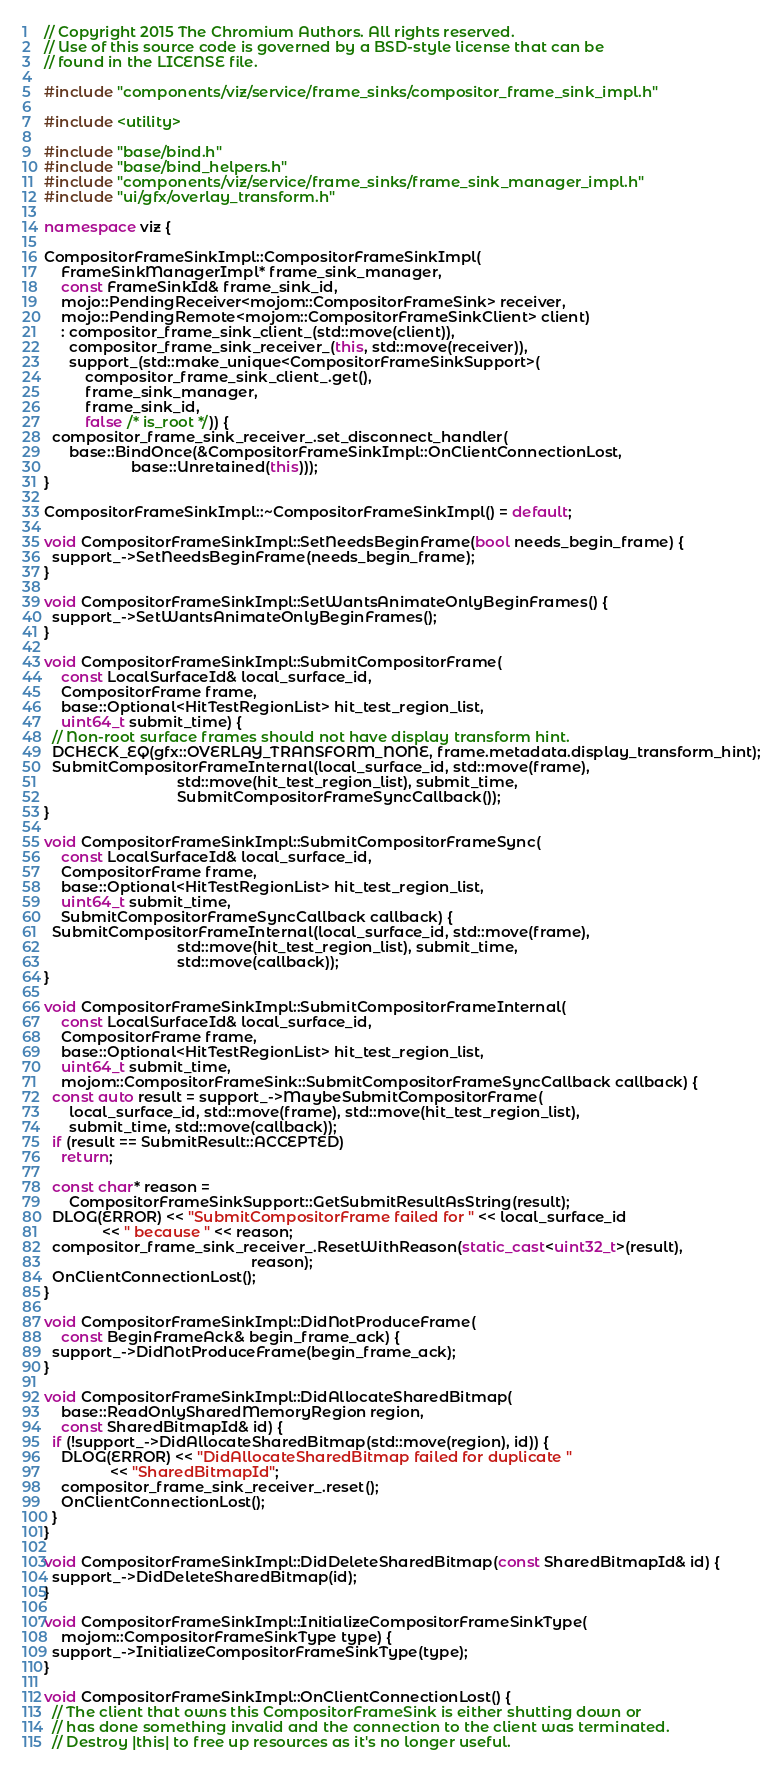Convert code to text. <code><loc_0><loc_0><loc_500><loc_500><_C++_>// Copyright 2015 The Chromium Authors. All rights reserved.
// Use of this source code is governed by a BSD-style license that can be
// found in the LICENSE file.

#include "components/viz/service/frame_sinks/compositor_frame_sink_impl.h"

#include <utility>

#include "base/bind.h"
#include "base/bind_helpers.h"
#include "components/viz/service/frame_sinks/frame_sink_manager_impl.h"
#include "ui/gfx/overlay_transform.h"

namespace viz {

CompositorFrameSinkImpl::CompositorFrameSinkImpl(
    FrameSinkManagerImpl* frame_sink_manager,
    const FrameSinkId& frame_sink_id,
    mojo::PendingReceiver<mojom::CompositorFrameSink> receiver,
    mojo::PendingRemote<mojom::CompositorFrameSinkClient> client)
    : compositor_frame_sink_client_(std::move(client)),
      compositor_frame_sink_receiver_(this, std::move(receiver)),
      support_(std::make_unique<CompositorFrameSinkSupport>(
          compositor_frame_sink_client_.get(),
          frame_sink_manager,
          frame_sink_id,
          false /* is_root */)) {
  compositor_frame_sink_receiver_.set_disconnect_handler(
      base::BindOnce(&CompositorFrameSinkImpl::OnClientConnectionLost,
                     base::Unretained(this)));
}

CompositorFrameSinkImpl::~CompositorFrameSinkImpl() = default;

void CompositorFrameSinkImpl::SetNeedsBeginFrame(bool needs_begin_frame) {
  support_->SetNeedsBeginFrame(needs_begin_frame);
}

void CompositorFrameSinkImpl::SetWantsAnimateOnlyBeginFrames() {
  support_->SetWantsAnimateOnlyBeginFrames();
}

void CompositorFrameSinkImpl::SubmitCompositorFrame(
    const LocalSurfaceId& local_surface_id,
    CompositorFrame frame,
    base::Optional<HitTestRegionList> hit_test_region_list,
    uint64_t submit_time) {
  // Non-root surface frames should not have display transform hint.
  DCHECK_EQ(gfx::OVERLAY_TRANSFORM_NONE, frame.metadata.display_transform_hint);
  SubmitCompositorFrameInternal(local_surface_id, std::move(frame),
                                std::move(hit_test_region_list), submit_time,
                                SubmitCompositorFrameSyncCallback());
}

void CompositorFrameSinkImpl::SubmitCompositorFrameSync(
    const LocalSurfaceId& local_surface_id,
    CompositorFrame frame,
    base::Optional<HitTestRegionList> hit_test_region_list,
    uint64_t submit_time,
    SubmitCompositorFrameSyncCallback callback) {
  SubmitCompositorFrameInternal(local_surface_id, std::move(frame),
                                std::move(hit_test_region_list), submit_time,
                                std::move(callback));
}

void CompositorFrameSinkImpl::SubmitCompositorFrameInternal(
    const LocalSurfaceId& local_surface_id,
    CompositorFrame frame,
    base::Optional<HitTestRegionList> hit_test_region_list,
    uint64_t submit_time,
    mojom::CompositorFrameSink::SubmitCompositorFrameSyncCallback callback) {
  const auto result = support_->MaybeSubmitCompositorFrame(
      local_surface_id, std::move(frame), std::move(hit_test_region_list),
      submit_time, std::move(callback));
  if (result == SubmitResult::ACCEPTED)
    return;

  const char* reason =
      CompositorFrameSinkSupport::GetSubmitResultAsString(result);
  DLOG(ERROR) << "SubmitCompositorFrame failed for " << local_surface_id
              << " because " << reason;
  compositor_frame_sink_receiver_.ResetWithReason(static_cast<uint32_t>(result),
                                                  reason);
  OnClientConnectionLost();
}

void CompositorFrameSinkImpl::DidNotProduceFrame(
    const BeginFrameAck& begin_frame_ack) {
  support_->DidNotProduceFrame(begin_frame_ack);
}

void CompositorFrameSinkImpl::DidAllocateSharedBitmap(
    base::ReadOnlySharedMemoryRegion region,
    const SharedBitmapId& id) {
  if (!support_->DidAllocateSharedBitmap(std::move(region), id)) {
    DLOG(ERROR) << "DidAllocateSharedBitmap failed for duplicate "
                << "SharedBitmapId";
    compositor_frame_sink_receiver_.reset();
    OnClientConnectionLost();
  }
}

void CompositorFrameSinkImpl::DidDeleteSharedBitmap(const SharedBitmapId& id) {
  support_->DidDeleteSharedBitmap(id);
}

void CompositorFrameSinkImpl::InitializeCompositorFrameSinkType(
    mojom::CompositorFrameSinkType type) {
  support_->InitializeCompositorFrameSinkType(type);
}

void CompositorFrameSinkImpl::OnClientConnectionLost() {
  // The client that owns this CompositorFrameSink is either shutting down or
  // has done something invalid and the connection to the client was terminated.
  // Destroy |this| to free up resources as it's no longer useful.</code> 